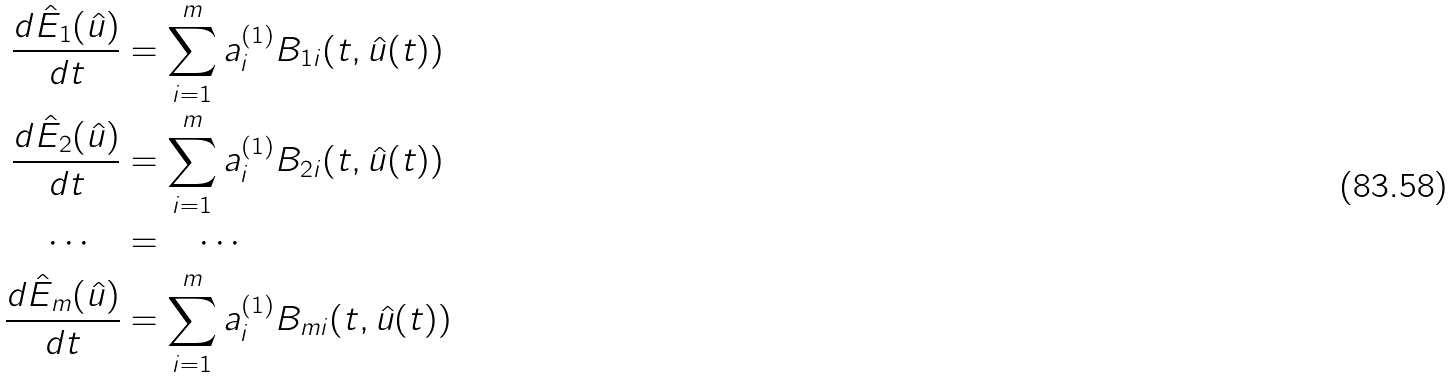<formula> <loc_0><loc_0><loc_500><loc_500>\frac { d \hat { E } _ { 1 } ( \hat { u } ) } { d t } & = \sum _ { i = 1 } ^ { m } a ^ { ( 1 ) } _ { i } B _ { 1 i } ( t , \hat { u } ( t ) ) \\ \frac { d \hat { E } _ { 2 } ( \hat { u } ) } { d t } & = \sum _ { i = 1 } ^ { m } a ^ { ( 1 ) } _ { i } B _ { 2 i } ( t , \hat { u } ( t ) ) \\ \quad \cdots \quad & = \quad \cdots \quad \\ \frac { d \hat { E } _ { m } ( \hat { u } ) } { d t } & = \sum _ { i = 1 } ^ { m } a ^ { ( 1 ) } _ { i } B _ { m i } ( t , \hat { u } ( t ) )</formula> 